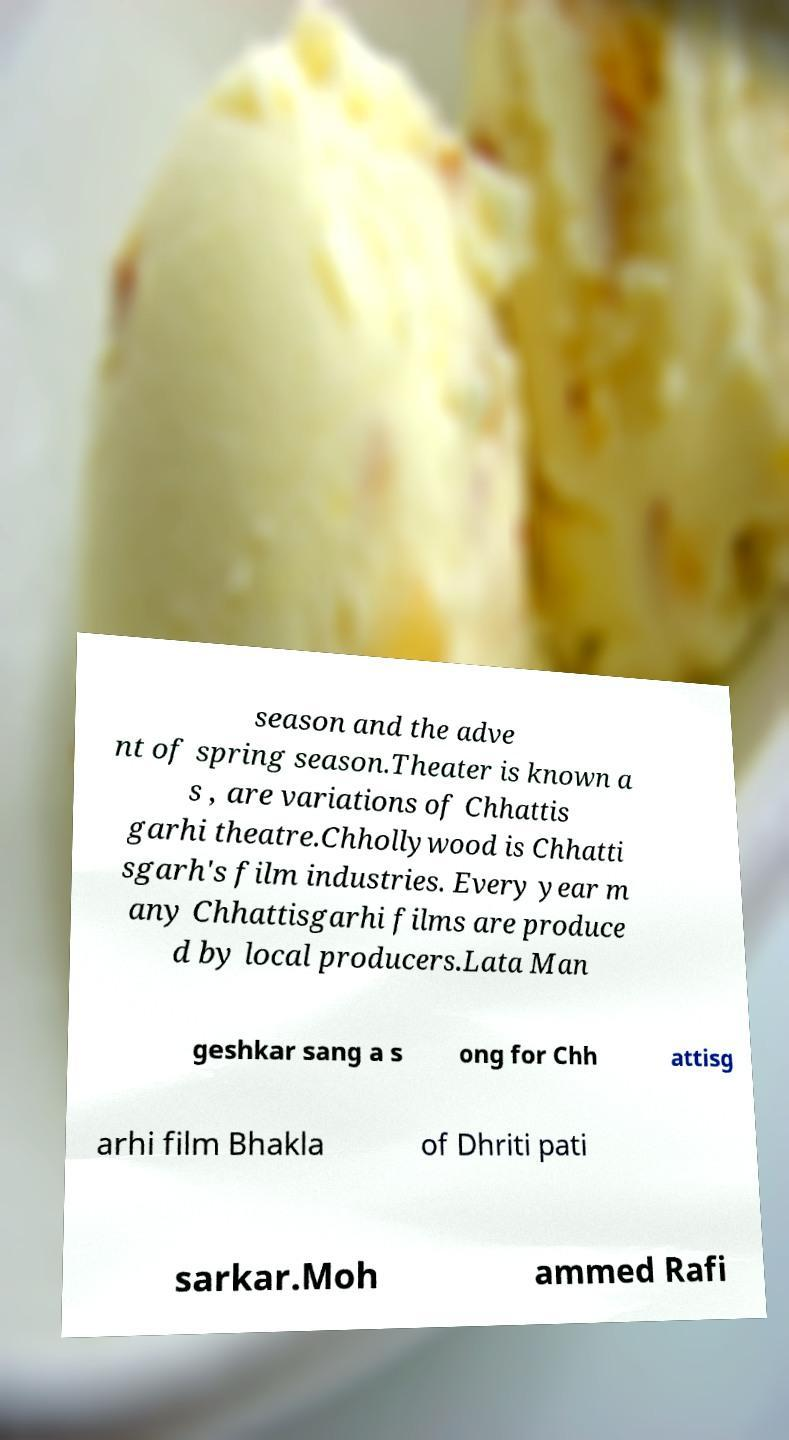What messages or text are displayed in this image? I need them in a readable, typed format. season and the adve nt of spring season.Theater is known a s , are variations of Chhattis garhi theatre.Chhollywood is Chhatti sgarh's film industries. Every year m any Chhattisgarhi films are produce d by local producers.Lata Man geshkar sang a s ong for Chh attisg arhi film Bhakla of Dhriti pati sarkar.Moh ammed Rafi 